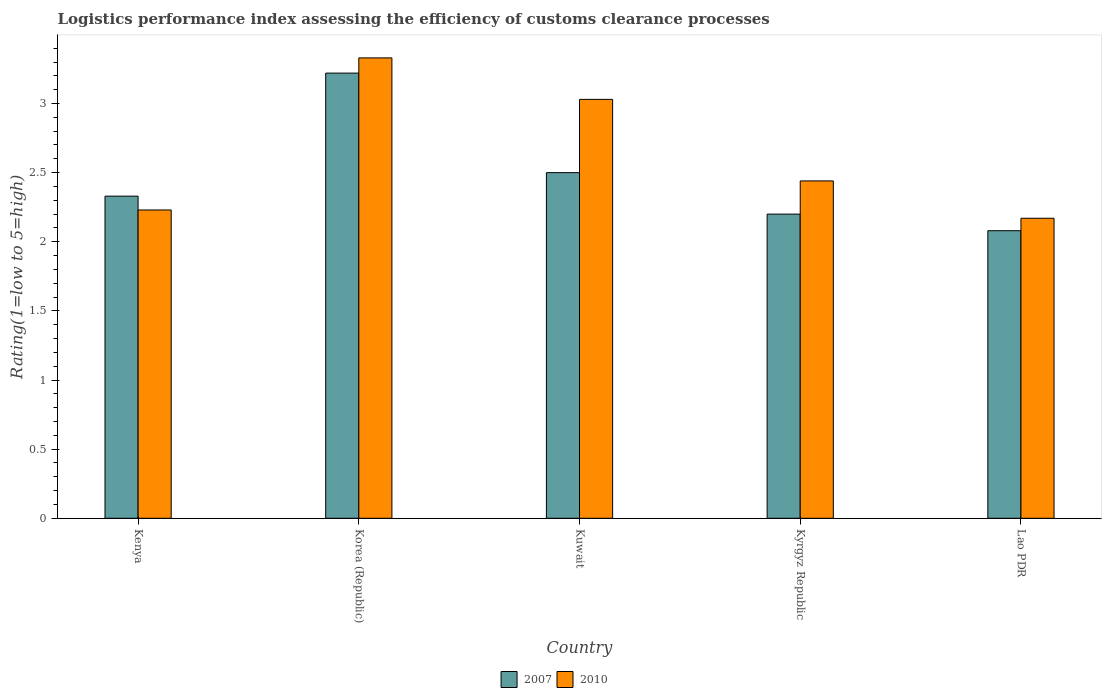How many different coloured bars are there?
Give a very brief answer. 2. Are the number of bars per tick equal to the number of legend labels?
Offer a terse response. Yes. Are the number of bars on each tick of the X-axis equal?
Provide a succinct answer. Yes. How many bars are there on the 2nd tick from the right?
Provide a succinct answer. 2. What is the label of the 5th group of bars from the left?
Ensure brevity in your answer.  Lao PDR. In how many cases, is the number of bars for a given country not equal to the number of legend labels?
Your answer should be compact. 0. Across all countries, what is the maximum Logistic performance index in 2007?
Ensure brevity in your answer.  3.22. Across all countries, what is the minimum Logistic performance index in 2010?
Provide a succinct answer. 2.17. In which country was the Logistic performance index in 2010 minimum?
Provide a succinct answer. Lao PDR. What is the total Logistic performance index in 2010 in the graph?
Give a very brief answer. 13.2. What is the difference between the Logistic performance index in 2010 in Kenya and that in Lao PDR?
Give a very brief answer. 0.06. What is the difference between the Logistic performance index in 2007 in Korea (Republic) and the Logistic performance index in 2010 in Kyrgyz Republic?
Make the answer very short. 0.78. What is the average Logistic performance index in 2007 per country?
Offer a very short reply. 2.47. What is the difference between the Logistic performance index of/in 2010 and Logistic performance index of/in 2007 in Kenya?
Offer a very short reply. -0.1. In how many countries, is the Logistic performance index in 2007 greater than 1.9?
Ensure brevity in your answer.  5. What is the ratio of the Logistic performance index in 2007 in Kuwait to that in Kyrgyz Republic?
Your answer should be very brief. 1.14. Is the Logistic performance index in 2010 in Kenya less than that in Lao PDR?
Ensure brevity in your answer.  No. What is the difference between the highest and the second highest Logistic performance index in 2010?
Keep it short and to the point. 0.59. What is the difference between the highest and the lowest Logistic performance index in 2010?
Offer a terse response. 1.16. In how many countries, is the Logistic performance index in 2010 greater than the average Logistic performance index in 2010 taken over all countries?
Offer a terse response. 2. Is the sum of the Logistic performance index in 2010 in Kenya and Kyrgyz Republic greater than the maximum Logistic performance index in 2007 across all countries?
Your response must be concise. Yes. What does the 1st bar from the right in Kenya represents?
Make the answer very short. 2010. How many countries are there in the graph?
Make the answer very short. 5. Are the values on the major ticks of Y-axis written in scientific E-notation?
Give a very brief answer. No. Where does the legend appear in the graph?
Give a very brief answer. Bottom center. How are the legend labels stacked?
Offer a very short reply. Horizontal. What is the title of the graph?
Offer a terse response. Logistics performance index assessing the efficiency of customs clearance processes. Does "1977" appear as one of the legend labels in the graph?
Provide a short and direct response. No. What is the label or title of the Y-axis?
Give a very brief answer. Rating(1=low to 5=high). What is the Rating(1=low to 5=high) of 2007 in Kenya?
Keep it short and to the point. 2.33. What is the Rating(1=low to 5=high) of 2010 in Kenya?
Offer a terse response. 2.23. What is the Rating(1=low to 5=high) in 2007 in Korea (Republic)?
Your answer should be compact. 3.22. What is the Rating(1=low to 5=high) in 2010 in Korea (Republic)?
Offer a terse response. 3.33. What is the Rating(1=low to 5=high) of 2010 in Kuwait?
Offer a terse response. 3.03. What is the Rating(1=low to 5=high) in 2010 in Kyrgyz Republic?
Give a very brief answer. 2.44. What is the Rating(1=low to 5=high) in 2007 in Lao PDR?
Give a very brief answer. 2.08. What is the Rating(1=low to 5=high) in 2010 in Lao PDR?
Your answer should be compact. 2.17. Across all countries, what is the maximum Rating(1=low to 5=high) in 2007?
Make the answer very short. 3.22. Across all countries, what is the maximum Rating(1=low to 5=high) in 2010?
Provide a short and direct response. 3.33. Across all countries, what is the minimum Rating(1=low to 5=high) of 2007?
Keep it short and to the point. 2.08. Across all countries, what is the minimum Rating(1=low to 5=high) of 2010?
Keep it short and to the point. 2.17. What is the total Rating(1=low to 5=high) of 2007 in the graph?
Make the answer very short. 12.33. What is the total Rating(1=low to 5=high) in 2010 in the graph?
Keep it short and to the point. 13.2. What is the difference between the Rating(1=low to 5=high) in 2007 in Kenya and that in Korea (Republic)?
Provide a succinct answer. -0.89. What is the difference between the Rating(1=low to 5=high) in 2007 in Kenya and that in Kuwait?
Make the answer very short. -0.17. What is the difference between the Rating(1=low to 5=high) in 2007 in Kenya and that in Kyrgyz Republic?
Give a very brief answer. 0.13. What is the difference between the Rating(1=low to 5=high) of 2010 in Kenya and that in Kyrgyz Republic?
Provide a succinct answer. -0.21. What is the difference between the Rating(1=low to 5=high) of 2007 in Kenya and that in Lao PDR?
Provide a short and direct response. 0.25. What is the difference between the Rating(1=low to 5=high) in 2010 in Kenya and that in Lao PDR?
Your answer should be very brief. 0.06. What is the difference between the Rating(1=low to 5=high) of 2007 in Korea (Republic) and that in Kuwait?
Make the answer very short. 0.72. What is the difference between the Rating(1=low to 5=high) of 2010 in Korea (Republic) and that in Kuwait?
Ensure brevity in your answer.  0.3. What is the difference between the Rating(1=low to 5=high) in 2010 in Korea (Republic) and that in Kyrgyz Republic?
Your answer should be compact. 0.89. What is the difference between the Rating(1=low to 5=high) in 2007 in Korea (Republic) and that in Lao PDR?
Provide a succinct answer. 1.14. What is the difference between the Rating(1=low to 5=high) of 2010 in Korea (Republic) and that in Lao PDR?
Provide a succinct answer. 1.16. What is the difference between the Rating(1=low to 5=high) in 2010 in Kuwait and that in Kyrgyz Republic?
Provide a short and direct response. 0.59. What is the difference between the Rating(1=low to 5=high) in 2007 in Kuwait and that in Lao PDR?
Your answer should be very brief. 0.42. What is the difference between the Rating(1=low to 5=high) of 2010 in Kuwait and that in Lao PDR?
Your answer should be very brief. 0.86. What is the difference between the Rating(1=low to 5=high) of 2007 in Kyrgyz Republic and that in Lao PDR?
Provide a succinct answer. 0.12. What is the difference between the Rating(1=low to 5=high) in 2010 in Kyrgyz Republic and that in Lao PDR?
Your answer should be very brief. 0.27. What is the difference between the Rating(1=low to 5=high) of 2007 in Kenya and the Rating(1=low to 5=high) of 2010 in Korea (Republic)?
Ensure brevity in your answer.  -1. What is the difference between the Rating(1=low to 5=high) in 2007 in Kenya and the Rating(1=low to 5=high) in 2010 in Kyrgyz Republic?
Ensure brevity in your answer.  -0.11. What is the difference between the Rating(1=low to 5=high) of 2007 in Kenya and the Rating(1=low to 5=high) of 2010 in Lao PDR?
Give a very brief answer. 0.16. What is the difference between the Rating(1=low to 5=high) in 2007 in Korea (Republic) and the Rating(1=low to 5=high) in 2010 in Kuwait?
Your response must be concise. 0.19. What is the difference between the Rating(1=low to 5=high) of 2007 in Korea (Republic) and the Rating(1=low to 5=high) of 2010 in Kyrgyz Republic?
Provide a succinct answer. 0.78. What is the difference between the Rating(1=low to 5=high) of 2007 in Korea (Republic) and the Rating(1=low to 5=high) of 2010 in Lao PDR?
Your response must be concise. 1.05. What is the difference between the Rating(1=low to 5=high) in 2007 in Kuwait and the Rating(1=low to 5=high) in 2010 in Kyrgyz Republic?
Your answer should be compact. 0.06. What is the difference between the Rating(1=low to 5=high) of 2007 in Kuwait and the Rating(1=low to 5=high) of 2010 in Lao PDR?
Give a very brief answer. 0.33. What is the difference between the Rating(1=low to 5=high) in 2007 in Kyrgyz Republic and the Rating(1=low to 5=high) in 2010 in Lao PDR?
Offer a terse response. 0.03. What is the average Rating(1=low to 5=high) of 2007 per country?
Your answer should be compact. 2.47. What is the average Rating(1=low to 5=high) in 2010 per country?
Provide a short and direct response. 2.64. What is the difference between the Rating(1=low to 5=high) in 2007 and Rating(1=low to 5=high) in 2010 in Korea (Republic)?
Provide a short and direct response. -0.11. What is the difference between the Rating(1=low to 5=high) of 2007 and Rating(1=low to 5=high) of 2010 in Kuwait?
Provide a short and direct response. -0.53. What is the difference between the Rating(1=low to 5=high) of 2007 and Rating(1=low to 5=high) of 2010 in Kyrgyz Republic?
Provide a short and direct response. -0.24. What is the difference between the Rating(1=low to 5=high) in 2007 and Rating(1=low to 5=high) in 2010 in Lao PDR?
Provide a short and direct response. -0.09. What is the ratio of the Rating(1=low to 5=high) in 2007 in Kenya to that in Korea (Republic)?
Provide a short and direct response. 0.72. What is the ratio of the Rating(1=low to 5=high) of 2010 in Kenya to that in Korea (Republic)?
Keep it short and to the point. 0.67. What is the ratio of the Rating(1=low to 5=high) in 2007 in Kenya to that in Kuwait?
Your answer should be very brief. 0.93. What is the ratio of the Rating(1=low to 5=high) in 2010 in Kenya to that in Kuwait?
Your response must be concise. 0.74. What is the ratio of the Rating(1=low to 5=high) of 2007 in Kenya to that in Kyrgyz Republic?
Your answer should be very brief. 1.06. What is the ratio of the Rating(1=low to 5=high) in 2010 in Kenya to that in Kyrgyz Republic?
Ensure brevity in your answer.  0.91. What is the ratio of the Rating(1=low to 5=high) in 2007 in Kenya to that in Lao PDR?
Ensure brevity in your answer.  1.12. What is the ratio of the Rating(1=low to 5=high) of 2010 in Kenya to that in Lao PDR?
Make the answer very short. 1.03. What is the ratio of the Rating(1=low to 5=high) of 2007 in Korea (Republic) to that in Kuwait?
Your response must be concise. 1.29. What is the ratio of the Rating(1=low to 5=high) of 2010 in Korea (Republic) to that in Kuwait?
Make the answer very short. 1.1. What is the ratio of the Rating(1=low to 5=high) in 2007 in Korea (Republic) to that in Kyrgyz Republic?
Keep it short and to the point. 1.46. What is the ratio of the Rating(1=low to 5=high) in 2010 in Korea (Republic) to that in Kyrgyz Republic?
Offer a terse response. 1.36. What is the ratio of the Rating(1=low to 5=high) of 2007 in Korea (Republic) to that in Lao PDR?
Offer a very short reply. 1.55. What is the ratio of the Rating(1=low to 5=high) in 2010 in Korea (Republic) to that in Lao PDR?
Your response must be concise. 1.53. What is the ratio of the Rating(1=low to 5=high) in 2007 in Kuwait to that in Kyrgyz Republic?
Provide a succinct answer. 1.14. What is the ratio of the Rating(1=low to 5=high) in 2010 in Kuwait to that in Kyrgyz Republic?
Offer a very short reply. 1.24. What is the ratio of the Rating(1=low to 5=high) of 2007 in Kuwait to that in Lao PDR?
Give a very brief answer. 1.2. What is the ratio of the Rating(1=low to 5=high) in 2010 in Kuwait to that in Lao PDR?
Give a very brief answer. 1.4. What is the ratio of the Rating(1=low to 5=high) in 2007 in Kyrgyz Republic to that in Lao PDR?
Your answer should be very brief. 1.06. What is the ratio of the Rating(1=low to 5=high) in 2010 in Kyrgyz Republic to that in Lao PDR?
Ensure brevity in your answer.  1.12. What is the difference between the highest and the second highest Rating(1=low to 5=high) of 2007?
Make the answer very short. 0.72. What is the difference between the highest and the lowest Rating(1=low to 5=high) of 2007?
Ensure brevity in your answer.  1.14. What is the difference between the highest and the lowest Rating(1=low to 5=high) of 2010?
Ensure brevity in your answer.  1.16. 